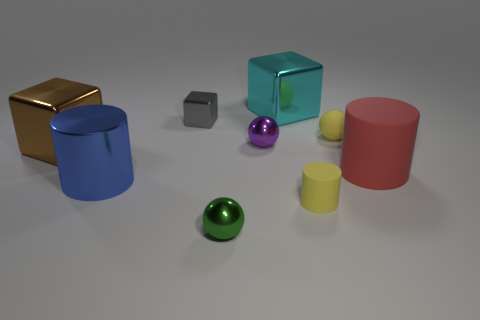Is the number of gray blocks that are behind the tiny gray metal thing the same as the number of cyan objects that are to the left of the blue cylinder?
Your answer should be very brief. Yes. What shape is the matte object that is the same color as the tiny matte sphere?
Offer a terse response. Cylinder. There is a object on the right side of the tiny yellow rubber sphere; what is it made of?
Make the answer very short. Rubber. Is the rubber sphere the same size as the cyan cube?
Give a very brief answer. No. Is the number of small metallic objects that are in front of the purple metallic sphere greater than the number of blue metal objects?
Make the answer very short. No. There is a cylinder that is made of the same material as the large brown cube; what size is it?
Give a very brief answer. Large. There is a brown shiny block; are there any things to the left of it?
Your response must be concise. No. Does the large blue metal thing have the same shape as the small purple thing?
Provide a short and direct response. No. There is a shiny sphere in front of the big metallic block left of the tiny metal ball that is in front of the brown metallic cube; what size is it?
Offer a very short reply. Small. What is the material of the purple object?
Your response must be concise. Metal. 